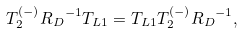<formula> <loc_0><loc_0><loc_500><loc_500>T ^ { ( - ) } _ { 2 } { R _ { D } } ^ { - 1 } T _ { L 1 } = T _ { L 1 } T ^ { ( - ) } _ { 2 } { R _ { D } } ^ { - 1 } ,</formula> 